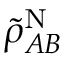Convert formula to latex. <formula><loc_0><loc_0><loc_500><loc_500>\tilde { \rho } _ { A B } ^ { N }</formula> 